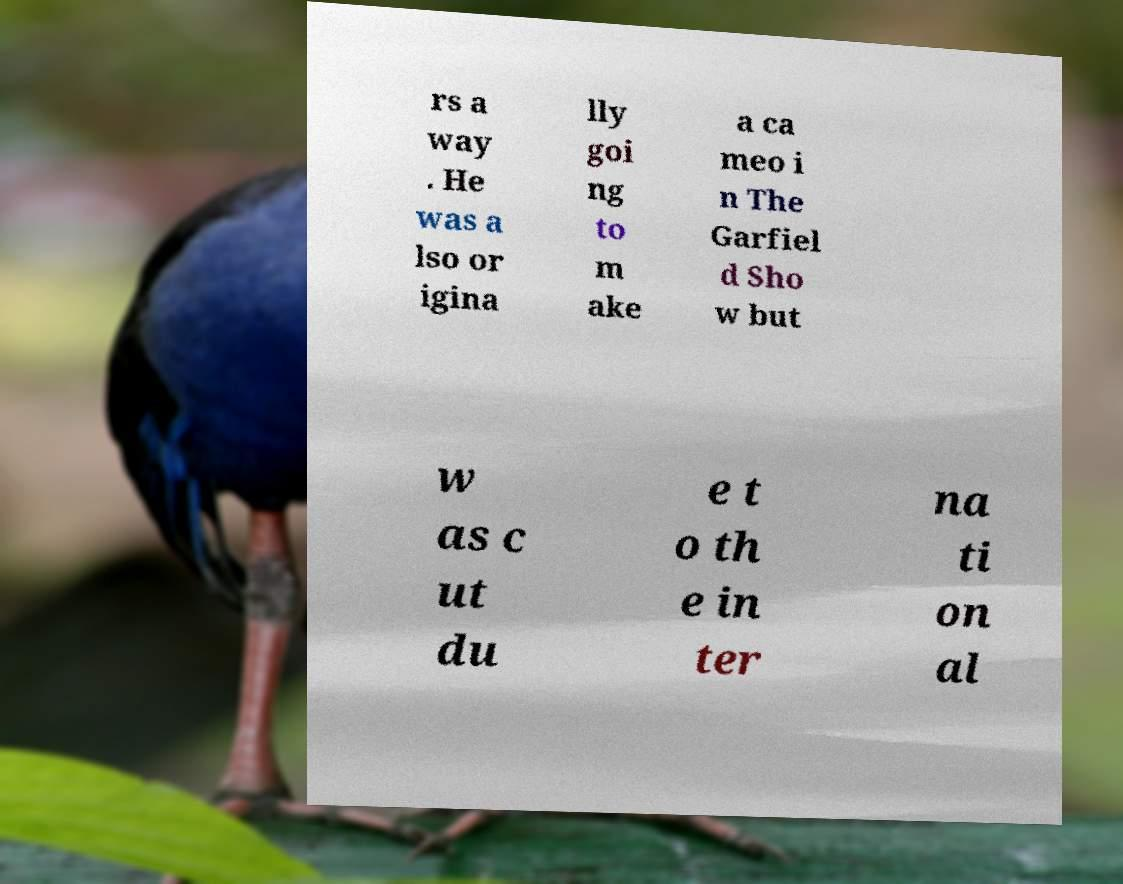I need the written content from this picture converted into text. Can you do that? rs a way . He was a lso or igina lly goi ng to m ake a ca meo i n The Garfiel d Sho w but w as c ut du e t o th e in ter na ti on al 